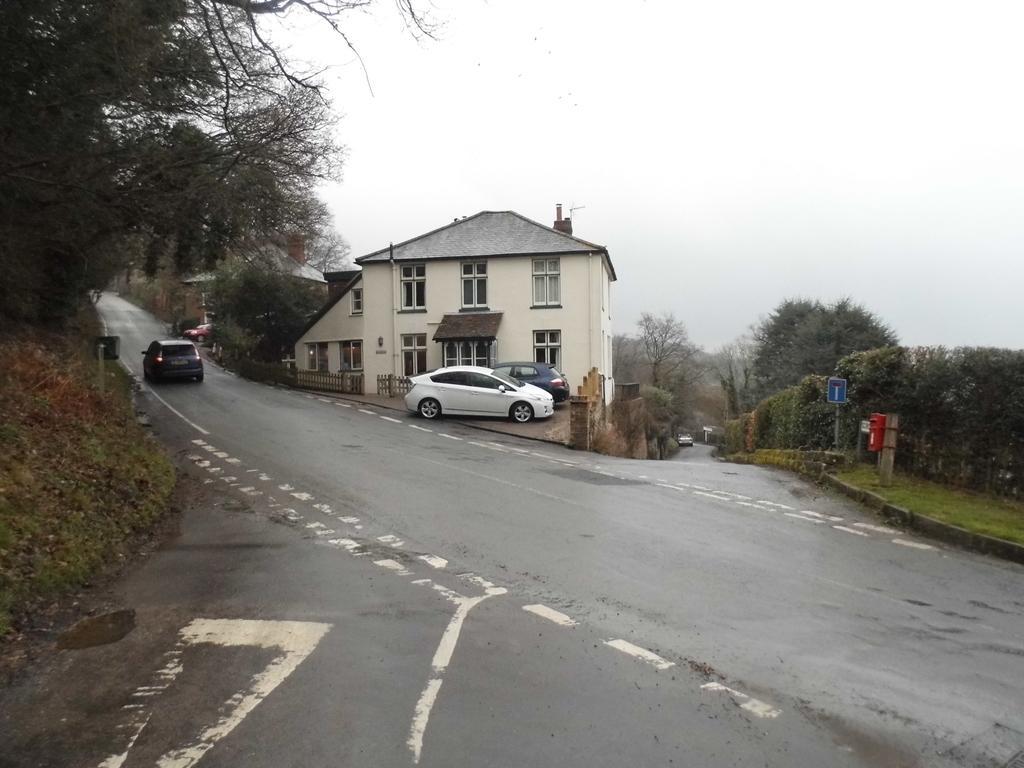How would you summarize this image in a sentence or two? In the center of the image we can see some cars parked on the road, a building with windows, door and roof, a fence. To the right side of the image we can see sign board, post box on the pole. In the background, we can see a group of trees, building, plants and the sky. 